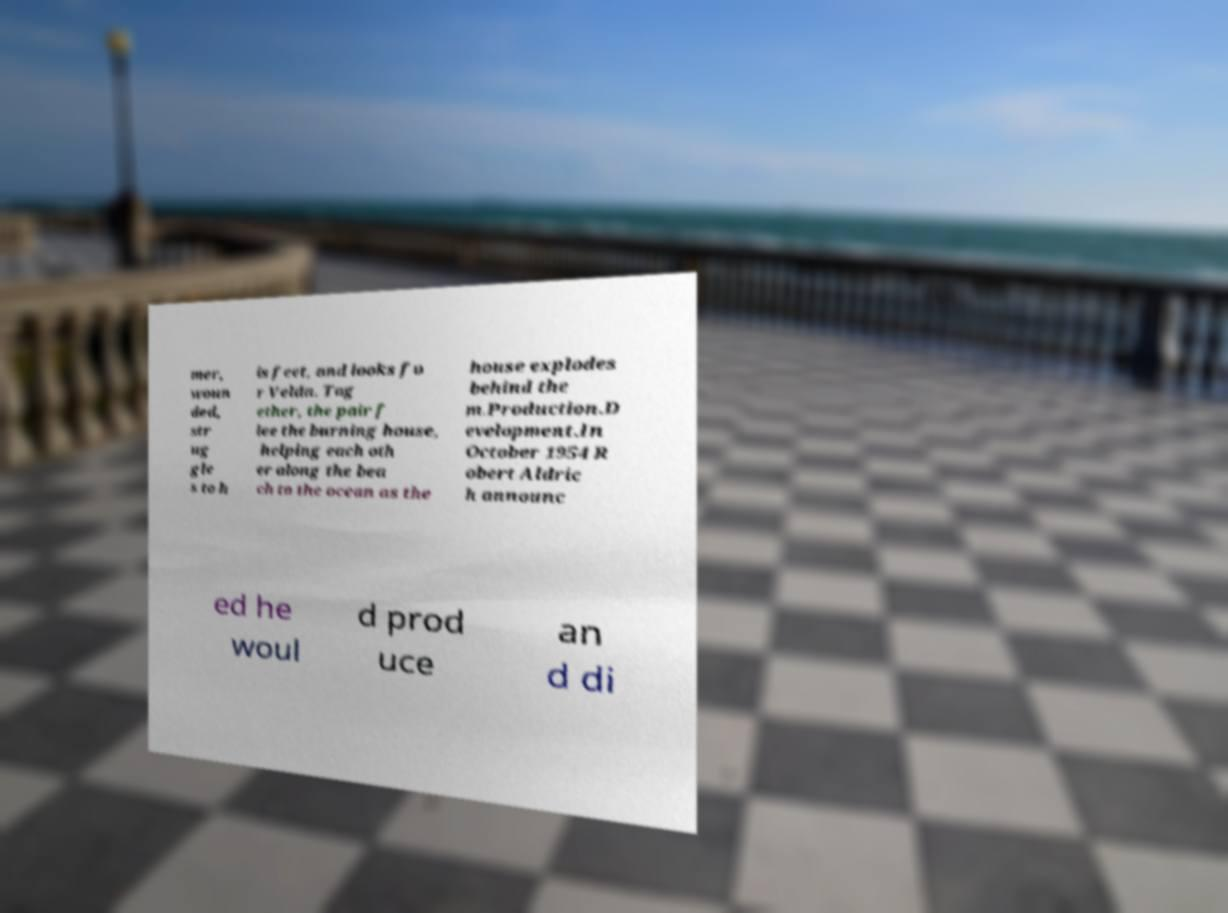There's text embedded in this image that I need extracted. Can you transcribe it verbatim? mer, woun ded, str ug gle s to h is feet, and looks fo r Velda. Tog ether, the pair f lee the burning house, helping each oth er along the bea ch to the ocean as the house explodes behind the m.Production.D evelopment.In October 1954 R obert Aldric h announc ed he woul d prod uce an d di 